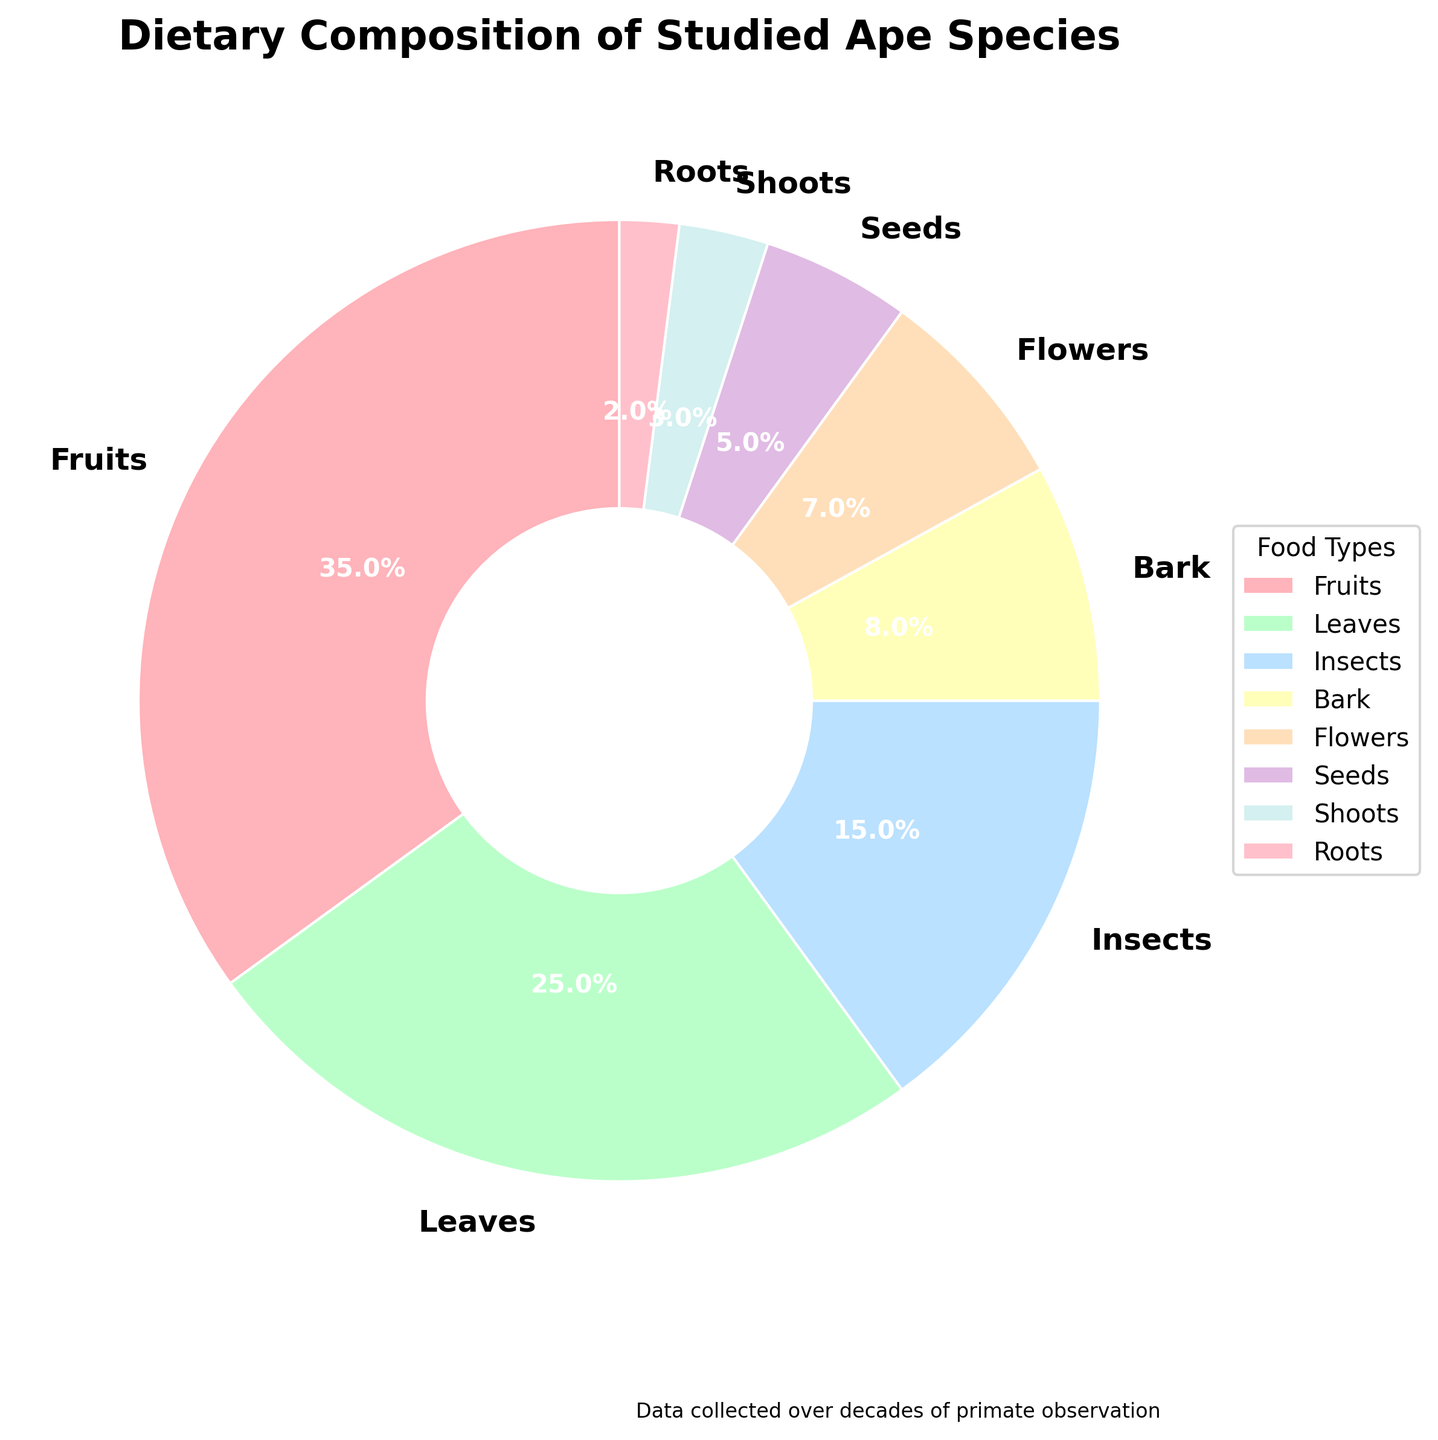What's the most common food type in the ape species' diet? The pie chart shows different food types with their respective percentages. The largest slice represents the most common food type.
Answer: Fruits How much more percentage do fruits constitute compared to seeds? To find how much more percentage fruits constitute, subtract the percentage of seeds from the percentage of fruits: 35% (fruits) - 5% (seeds).
Answer: 30% What is the combined percentage of leaves and insects in the diet? To find the combined percentage, add the percentage of leaves and the percentage of insects: 25% (leaves) + 15% (insects).
Answer: 40% Which food type occupies the smallest portion of the diet? The smallest portion of the pie chart represents the food type with the lowest percentage.
Answer: Roots Are fruits and flowers equally represented in the ape's diet? If not, by how much do they differ? Compare the percentages of fruits (35%) and flowers (7%). Subtract the smaller percentage from the larger one to find the difference: 35% - 7%.
Answer: No, 28% How does the percentage of bark compare to that of seeds? Compare the percentages of bark (8%) and seeds (5%). Bark percentage is higher.
Answer: Bark is 3% higher What is the total percentage of food types other than fruits, leaves, and insects? Subtract the combined percentage of fruits, leaves, and insects from 100%: 100% - (35% + 25% + 15%).
Answer: 25% What food type percentage is closest to that of bark? Look for the food type with a percentage closest to 8% (bark).
Answer: Flowers (7%) Which food types are present in equal or nearly equal proportions in the diet? Compare the percentages of food types to find those with similar values.
Answer: Flowers and Seeds What percentage of the diet is composed of non-plant food types? Add the percentage of insects, the only non-plant food type: 15%.
Answer: 15% 